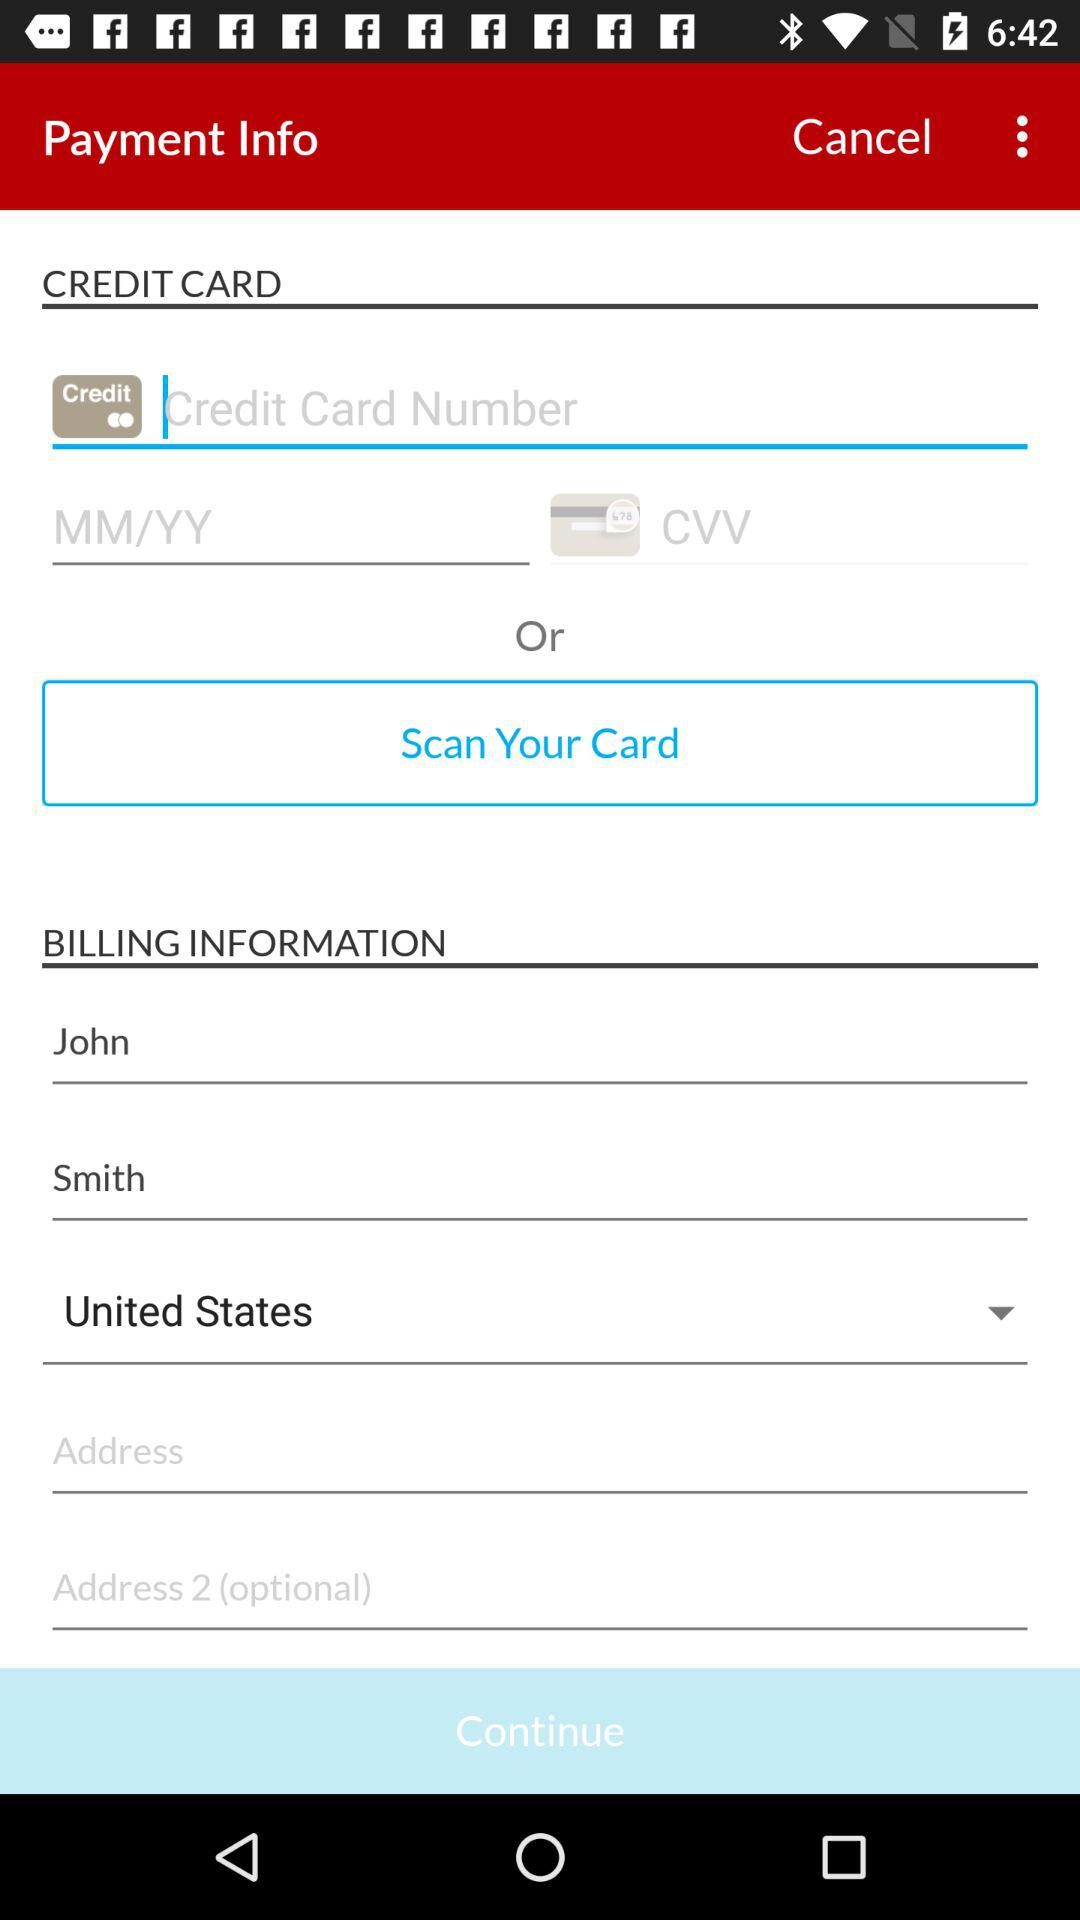What is the first name of the user? The first name of the user is John. 